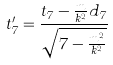Convert formula to latex. <formula><loc_0><loc_0><loc_500><loc_500>t _ { 7 } ^ { \prime } = \frac { t _ { 7 } - \frac { m } { k ^ { 2 } } d _ { 7 } } { \sqrt { 7 - \frac { m ^ { 2 } } { k ^ { 2 } } } }</formula> 